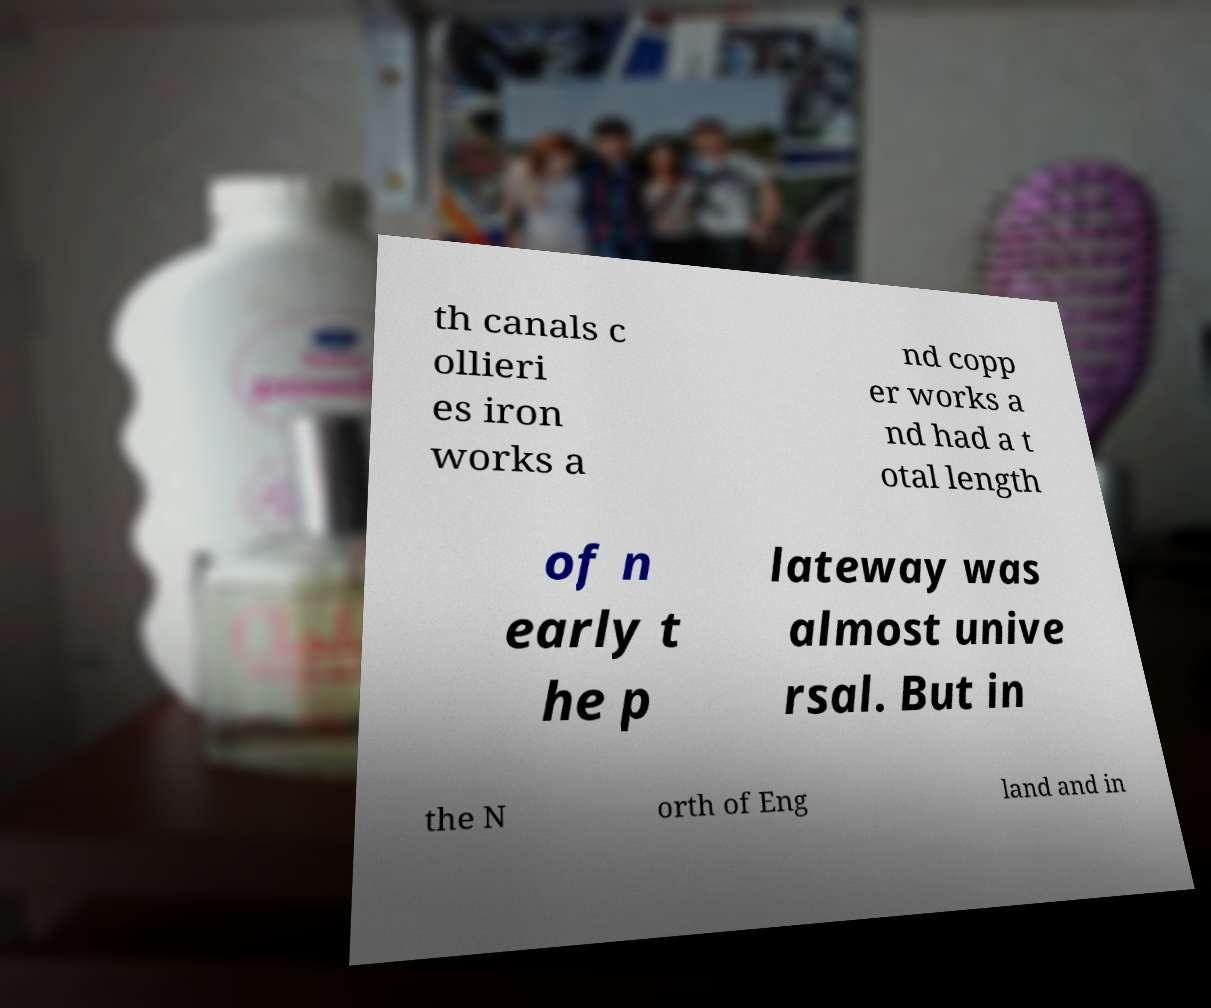Please identify and transcribe the text found in this image. th canals c ollieri es iron works a nd copp er works a nd had a t otal length of n early t he p lateway was almost unive rsal. But in the N orth of Eng land and in 